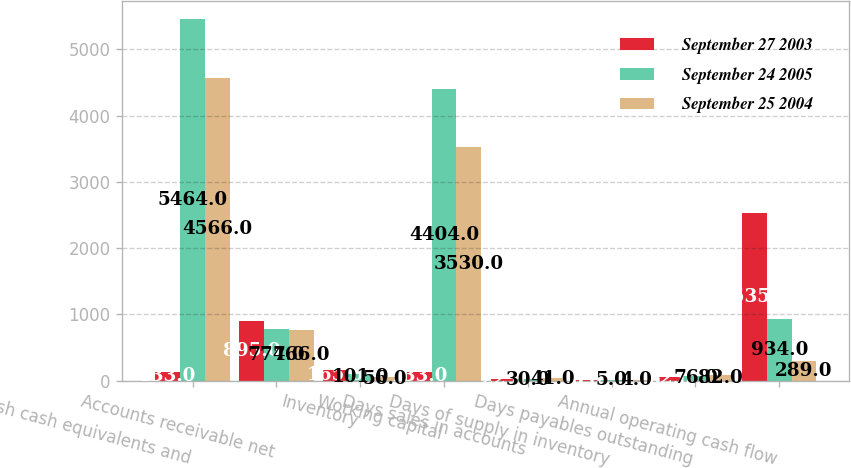<chart> <loc_0><loc_0><loc_500><loc_500><stacked_bar_chart><ecel><fcel>Cash cash equivalents and<fcel>Accounts receivable net<fcel>Inventory<fcel>Working capital<fcel>Days sales in accounts<fcel>Days of supply in inventory<fcel>Days payables outstanding<fcel>Annual operating cash flow<nl><fcel>September 27 2003<fcel>133<fcel>895<fcel>165<fcel>133<fcel>22<fcel>6<fcel>62<fcel>2535<nl><fcel>September 24 2005<fcel>5464<fcel>774<fcel>101<fcel>4404<fcel>30<fcel>5<fcel>76<fcel>934<nl><fcel>September 25 2004<fcel>4566<fcel>766<fcel>56<fcel>3530<fcel>41<fcel>4<fcel>82<fcel>289<nl></chart> 